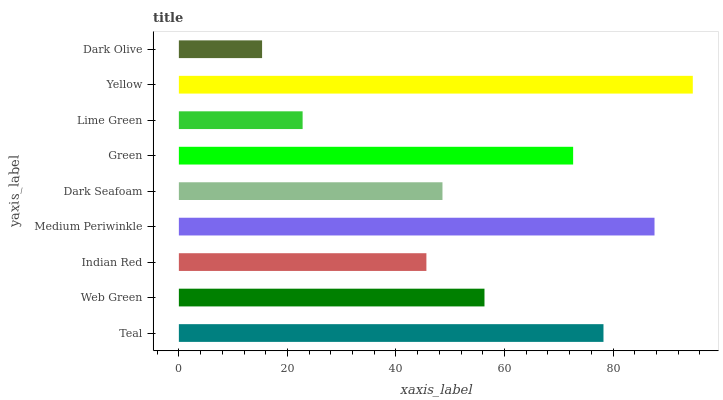Is Dark Olive the minimum?
Answer yes or no. Yes. Is Yellow the maximum?
Answer yes or no. Yes. Is Web Green the minimum?
Answer yes or no. No. Is Web Green the maximum?
Answer yes or no. No. Is Teal greater than Web Green?
Answer yes or no. Yes. Is Web Green less than Teal?
Answer yes or no. Yes. Is Web Green greater than Teal?
Answer yes or no. No. Is Teal less than Web Green?
Answer yes or no. No. Is Web Green the high median?
Answer yes or no. Yes. Is Web Green the low median?
Answer yes or no. Yes. Is Teal the high median?
Answer yes or no. No. Is Lime Green the low median?
Answer yes or no. No. 